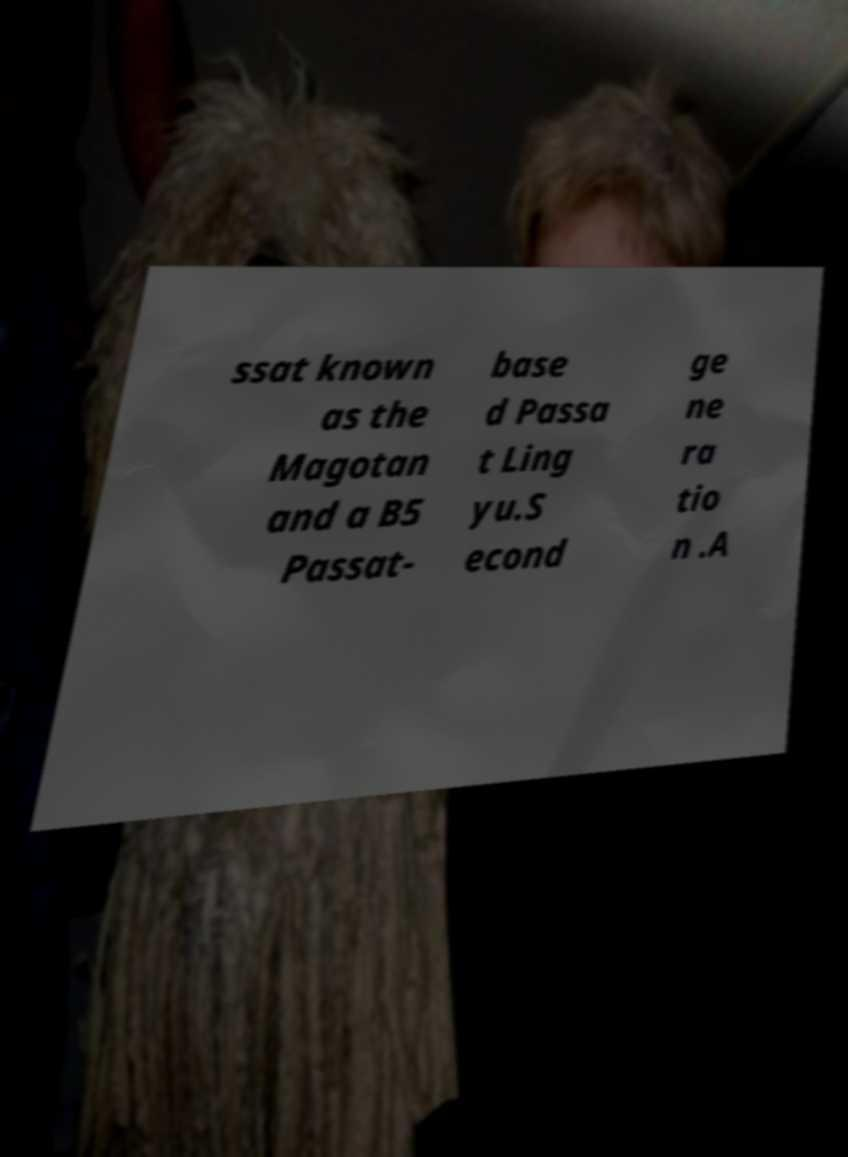Please identify and transcribe the text found in this image. ssat known as the Magotan and a B5 Passat- base d Passa t Ling yu.S econd ge ne ra tio n .A 